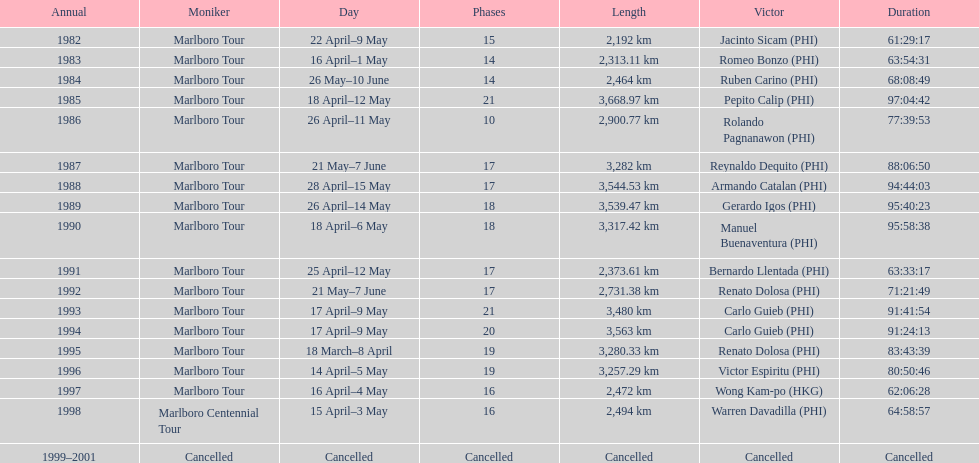Whose name is listed just ahead of wong kam-po? Victor Espiritu (PHI). 